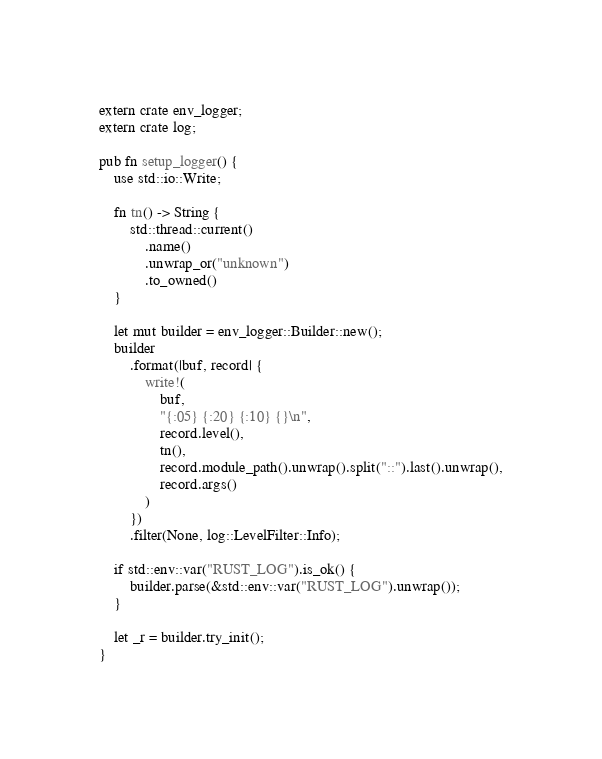<code> <loc_0><loc_0><loc_500><loc_500><_Rust_>extern crate env_logger;
extern crate log;

pub fn setup_logger() {
    use std::io::Write;

    fn tn() -> String {
        std::thread::current()
            .name()
            .unwrap_or("unknown")
            .to_owned()
    }

    let mut builder = env_logger::Builder::new();
    builder
        .format(|buf, record| {
            write!(
                buf,
                "{:05} {:20} {:10} {}\n",
                record.level(),
                tn(),
                record.module_path().unwrap().split("::").last().unwrap(),
                record.args()
            )
        })
        .filter(None, log::LevelFilter::Info);

    if std::env::var("RUST_LOG").is_ok() {
        builder.parse(&std::env::var("RUST_LOG").unwrap());
    }

    let _r = builder.try_init();
}
</code> 